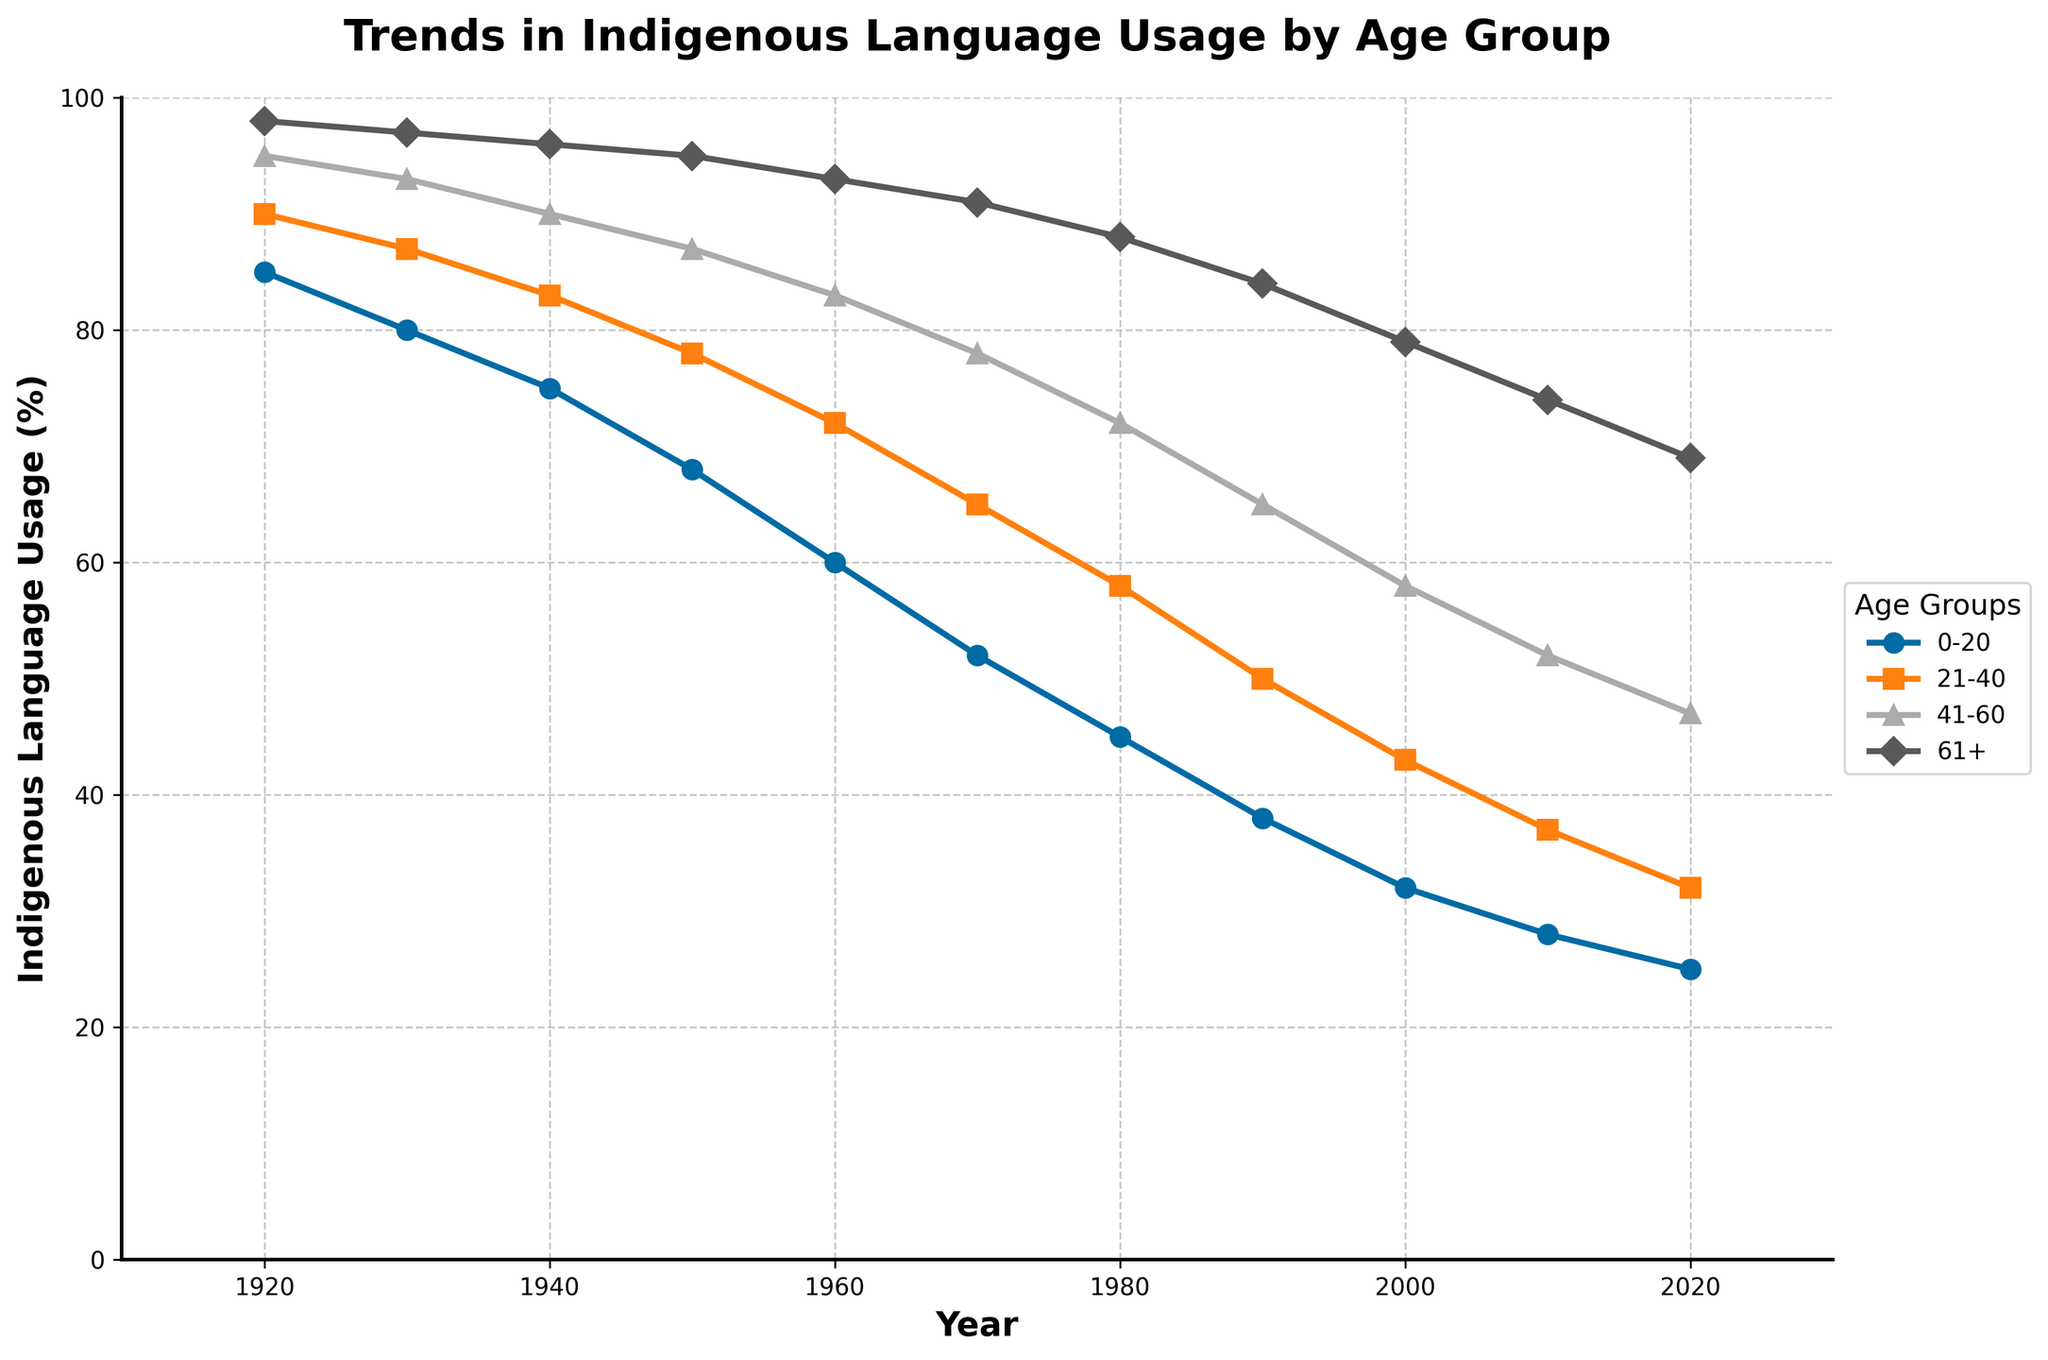What is the overall trend in indigenous language usage in the 0-20 age group from 1920 to 2020? The usage percentage in the 0-20 age group decreases over time from 85% in 1920 to 25% in 2020. By examining the slope of the line representing this age group, we observe a consistent downward trend.
Answer: Decreasing Which age group had the highest indigenous language usage in 1950? For the year 1950, the data points show 68% (0-20), 78% (21-40), 87% (41-60), and 95% (61+). The 61+ age group has the highest usage percentage.
Answer: 61+ How does the indigenous language usage in the 61+ age group in 2020 compare to that in 1920? In 1920, the usage for 61+ was 98%, and in 2020, it was 69%. Thus, it decreased by 29 percentage points over the century.
Answer: Decreased Which decade saw the largest decrease in language usage for the 21-40 age group? By calculating the differences between each decade: 1920-1930: -3%, 1930-1940: -4%, 1940-1950: -5%, 1950-1960: -6%, 1960-1970: -7%, 1970-1980: -7%, 1980-1990: -8%, 1990-2000: -7%, 2000-2010: -6%, 2010-2020: -5%, the largest decrease, 8%, occurs between 1980 and 1990.
Answer: 1980-1990 What is the average indigenous language usage among all age groups in 1970? The usage for 1970 is 52% (0-20), 65% (21-40), 78% (41-60), 91% (61+). Adding them gives: 52 + 65 + 78 + 91 = 286. Dividing by 4 age groups, the average is 286 / 4 = 71.5%.
Answer: 71.5% Identify the age group whose indigenous language usage has been declining at the fastest rate across the century. By calculating the total percentage decrease from 1920 to 2020 for each group: 0-20: 85-25=60, 21-40: 90-32=58, 41-60: 95-47=48, 61+: 98-69=29, the fastest declining group is the 0-20 age group, which decreased by 60 percentage points.
Answer: 0-20 